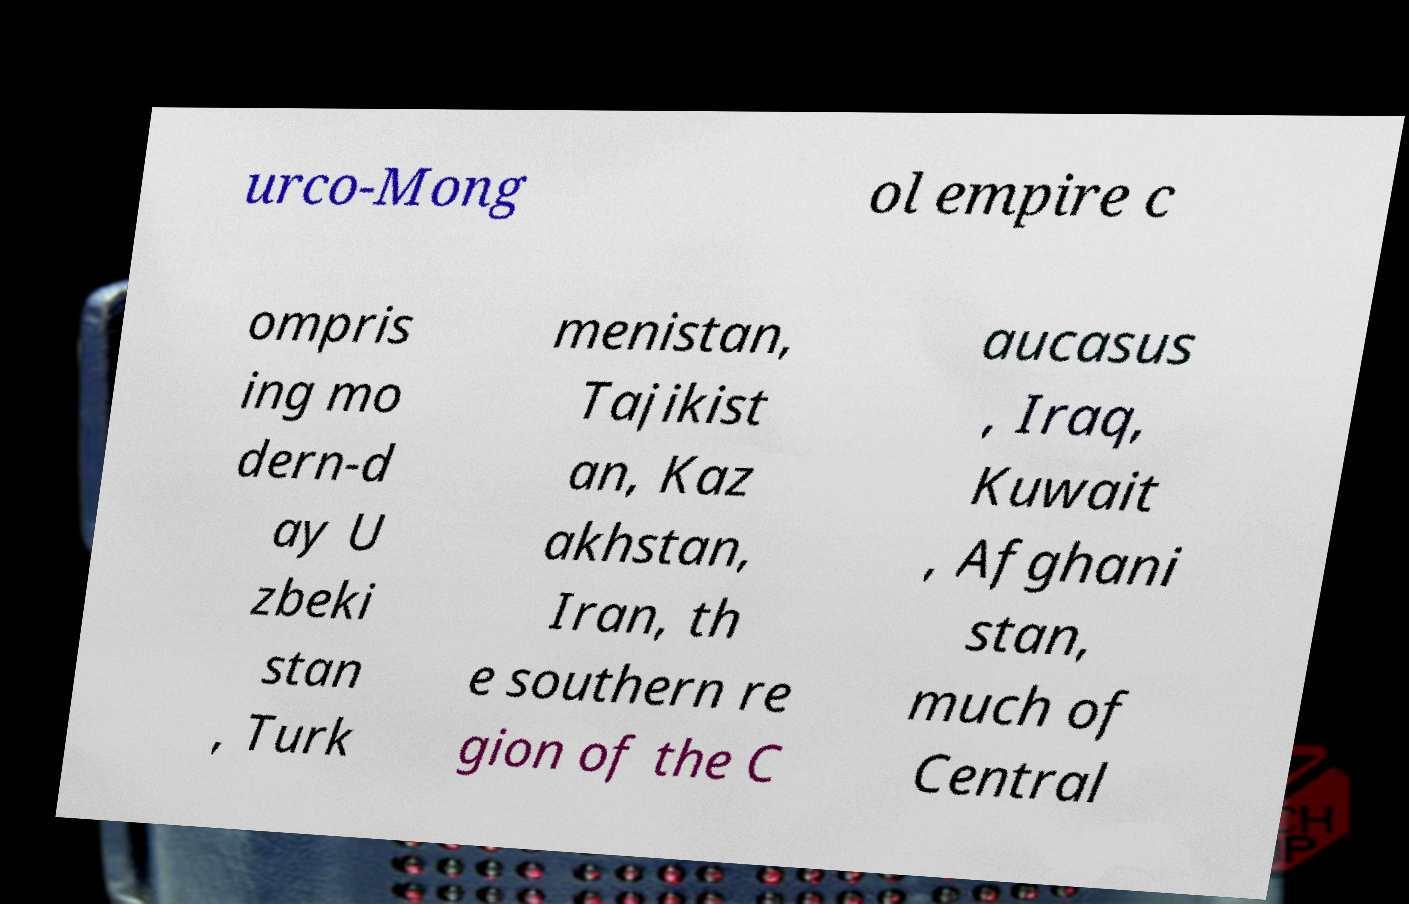Please read and relay the text visible in this image. What does it say? urco-Mong ol empire c ompris ing mo dern-d ay U zbeki stan , Turk menistan, Tajikist an, Kaz akhstan, Iran, th e southern re gion of the C aucasus , Iraq, Kuwait , Afghani stan, much of Central 